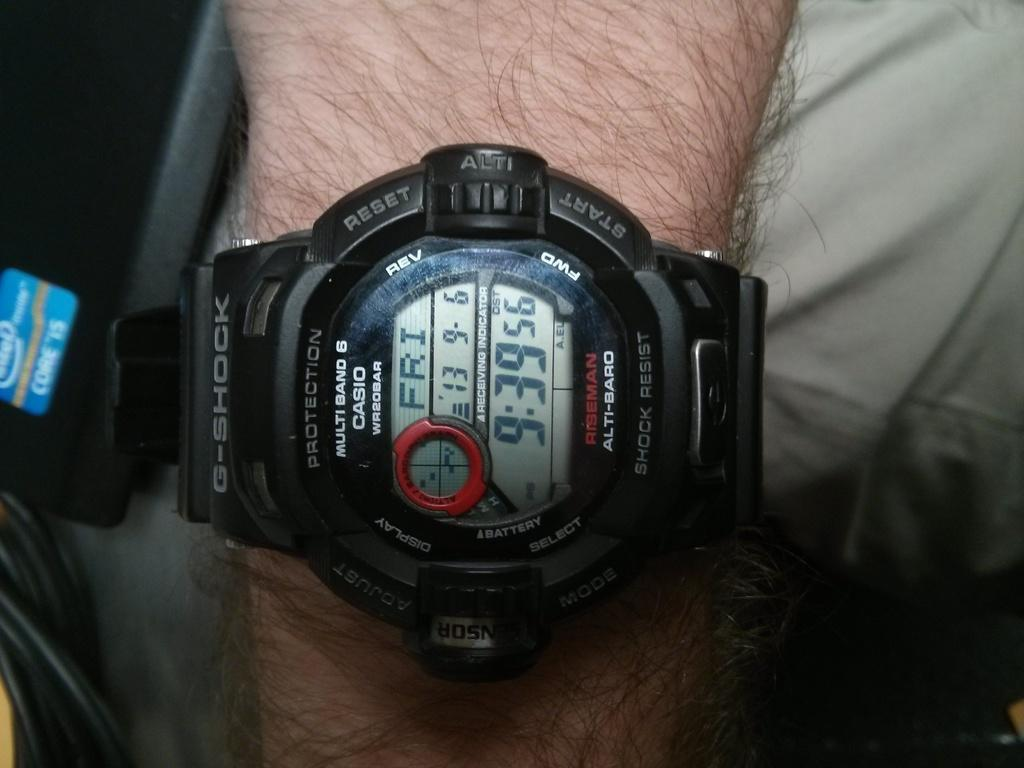Provide a one-sentence caption for the provided image. G Shock black and red watch that contains the date and time. 